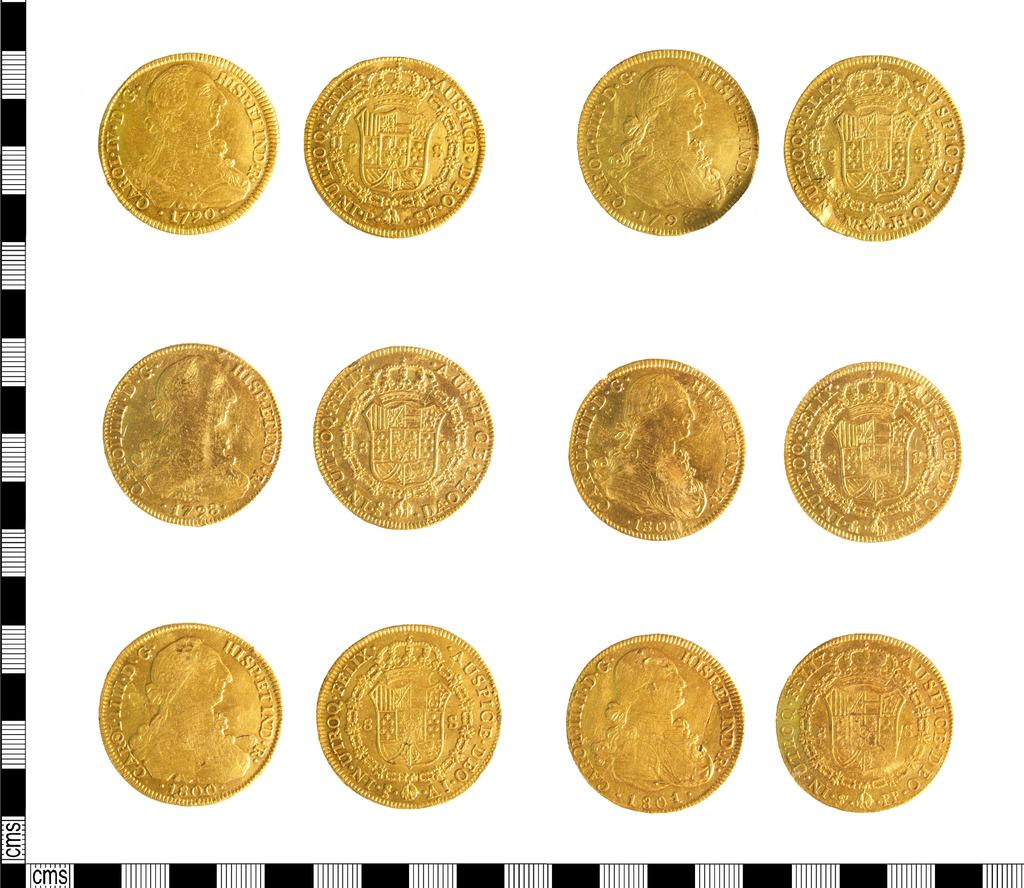<image>
Create a compact narrative representing the image presented. The front and back of some gold coins from the 1790's and early 1800's with In Utroq Felix and Auspice Deo on the perimeter. 